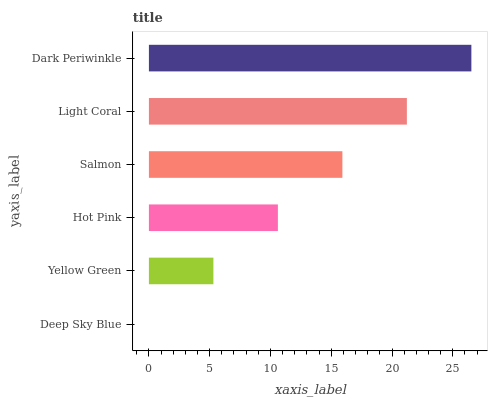Is Deep Sky Blue the minimum?
Answer yes or no. Yes. Is Dark Periwinkle the maximum?
Answer yes or no. Yes. Is Yellow Green the minimum?
Answer yes or no. No. Is Yellow Green the maximum?
Answer yes or no. No. Is Yellow Green greater than Deep Sky Blue?
Answer yes or no. Yes. Is Deep Sky Blue less than Yellow Green?
Answer yes or no. Yes. Is Deep Sky Blue greater than Yellow Green?
Answer yes or no. No. Is Yellow Green less than Deep Sky Blue?
Answer yes or no. No. Is Salmon the high median?
Answer yes or no. Yes. Is Hot Pink the low median?
Answer yes or no. Yes. Is Light Coral the high median?
Answer yes or no. No. Is Salmon the low median?
Answer yes or no. No. 